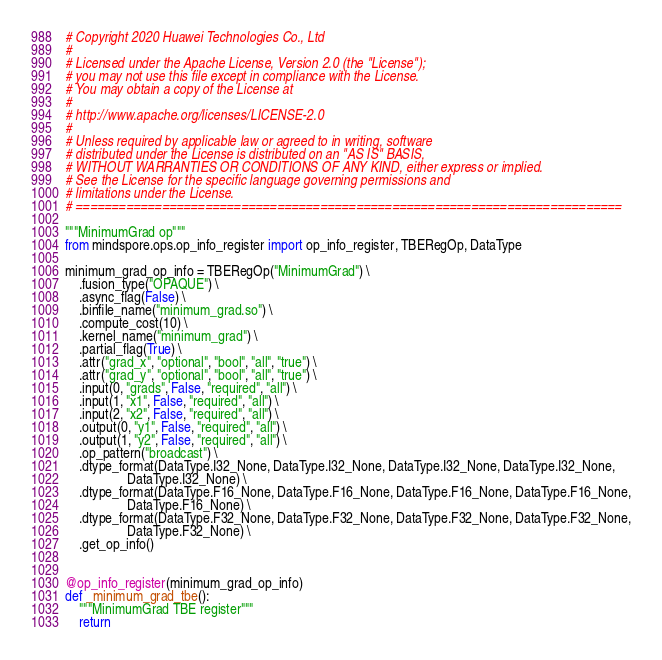<code> <loc_0><loc_0><loc_500><loc_500><_Python_># Copyright 2020 Huawei Technologies Co., Ltd
#
# Licensed under the Apache License, Version 2.0 (the "License");
# you may not use this file except in compliance with the License.
# You may obtain a copy of the License at
#
# http://www.apache.org/licenses/LICENSE-2.0
#
# Unless required by applicable law or agreed to in writing, software
# distributed under the License is distributed on an "AS IS" BASIS,
# WITHOUT WARRANTIES OR CONDITIONS OF ANY KIND, either express or implied.
# See the License for the specific language governing permissions and
# limitations under the License.
# ============================================================================

"""MinimumGrad op"""
from mindspore.ops.op_info_register import op_info_register, TBERegOp, DataType

minimum_grad_op_info = TBERegOp("MinimumGrad") \
    .fusion_type("OPAQUE") \
    .async_flag(False) \
    .binfile_name("minimum_grad.so") \
    .compute_cost(10) \
    .kernel_name("minimum_grad") \
    .partial_flag(True) \
    .attr("grad_x", "optional", "bool", "all", "true") \
    .attr("grad_y", "optional", "bool", "all", "true") \
    .input(0, "grads", False, "required", "all") \
    .input(1, "x1", False, "required", "all") \
    .input(2, "x2", False, "required", "all") \
    .output(0, "y1", False, "required", "all") \
    .output(1, "y2", False, "required", "all") \
    .op_pattern("broadcast") \
    .dtype_format(DataType.I32_None, DataType.I32_None, DataType.I32_None, DataType.I32_None,
                  DataType.I32_None) \
    .dtype_format(DataType.F16_None, DataType.F16_None, DataType.F16_None, DataType.F16_None,
                  DataType.F16_None) \
    .dtype_format(DataType.F32_None, DataType.F32_None, DataType.F32_None, DataType.F32_None,
                  DataType.F32_None) \
    .get_op_info()


@op_info_register(minimum_grad_op_info)
def _minimum_grad_tbe():
    """MinimumGrad TBE register"""
    return
</code> 